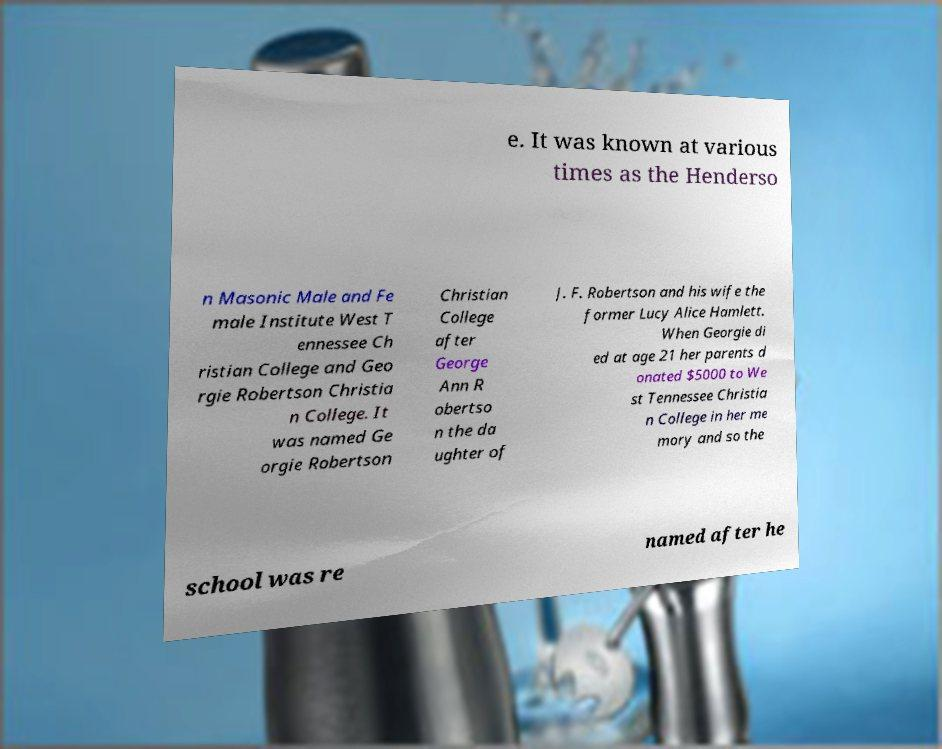There's text embedded in this image that I need extracted. Can you transcribe it verbatim? e. It was known at various times as the Henderso n Masonic Male and Fe male Institute West T ennessee Ch ristian College and Geo rgie Robertson Christia n College. It was named Ge orgie Robertson Christian College after George Ann R obertso n the da ughter of J. F. Robertson and his wife the former Lucy Alice Hamlett. When Georgie di ed at age 21 her parents d onated $5000 to We st Tennessee Christia n College in her me mory and so the school was re named after he 